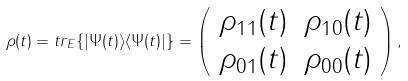Convert formula to latex. <formula><loc_0><loc_0><loc_500><loc_500>\rho ( t ) = t r _ { E } \{ | \Psi ( t ) \rangle \langle \Psi ( t ) | \} = \left ( \begin{array} { c c } \rho _ { 1 1 } ( t ) & \rho _ { 1 0 } ( t ) \\ \rho _ { 0 1 } ( t ) & \rho _ { 0 0 } ( t ) \end{array} \right ) ,</formula> 